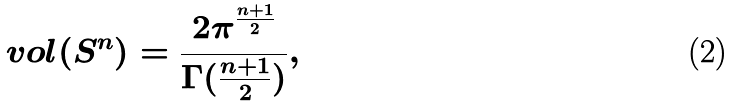<formula> <loc_0><loc_0><loc_500><loc_500>\ v o l ( S ^ { n } ) = \frac { 2 \pi ^ { \frac { n + 1 } { 2 } } } { \Gamma ( \frac { n + 1 } { 2 } ) } ,</formula> 